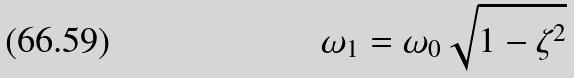Convert formula to latex. <formula><loc_0><loc_0><loc_500><loc_500>\omega _ { 1 } = \omega _ { 0 } \sqrt { 1 - \zeta ^ { 2 } }</formula> 